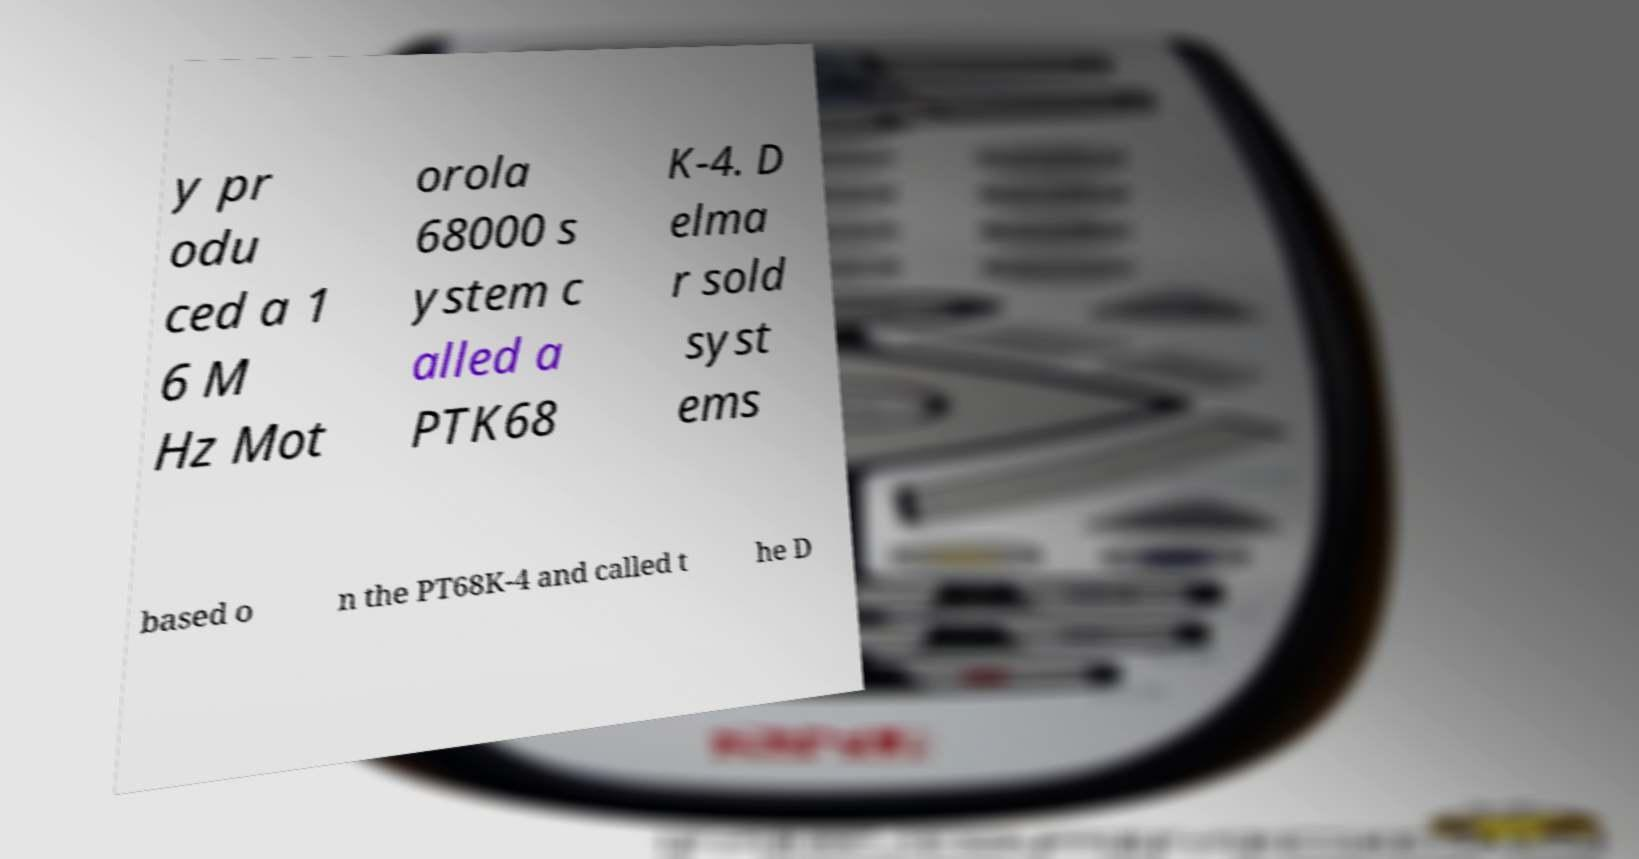There's text embedded in this image that I need extracted. Can you transcribe it verbatim? y pr odu ced a 1 6 M Hz Mot orola 68000 s ystem c alled a PTK68 K-4. D elma r sold syst ems based o n the PT68K-4 and called t he D 